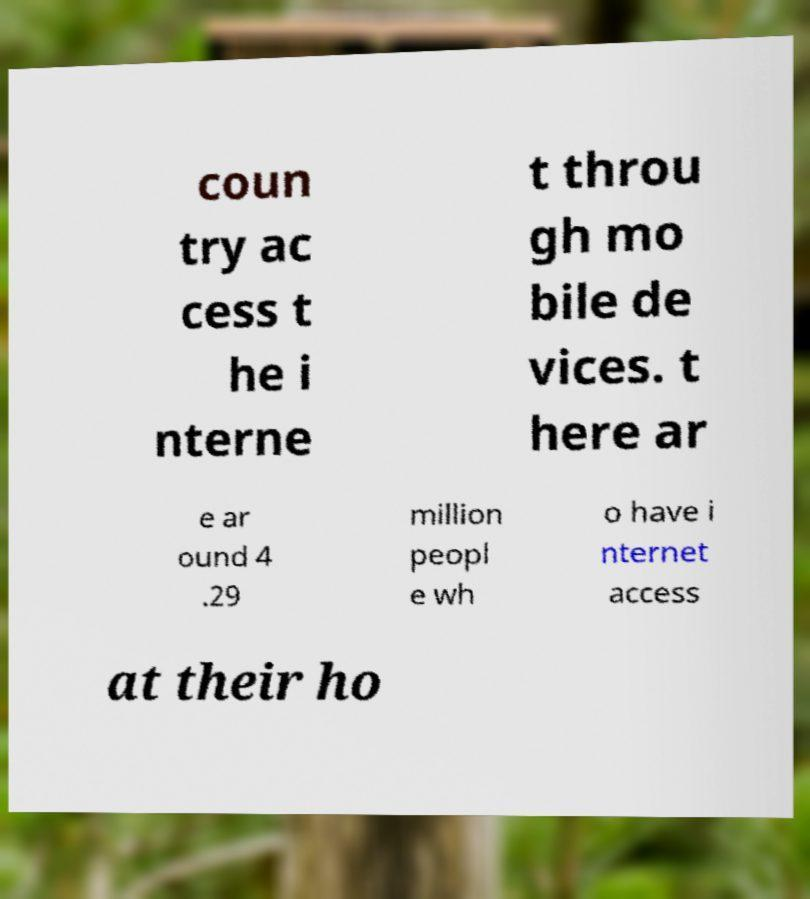Can you read and provide the text displayed in the image?This photo seems to have some interesting text. Can you extract and type it out for me? coun try ac cess t he i nterne t throu gh mo bile de vices. t here ar e ar ound 4 .29 million peopl e wh o have i nternet access at their ho 